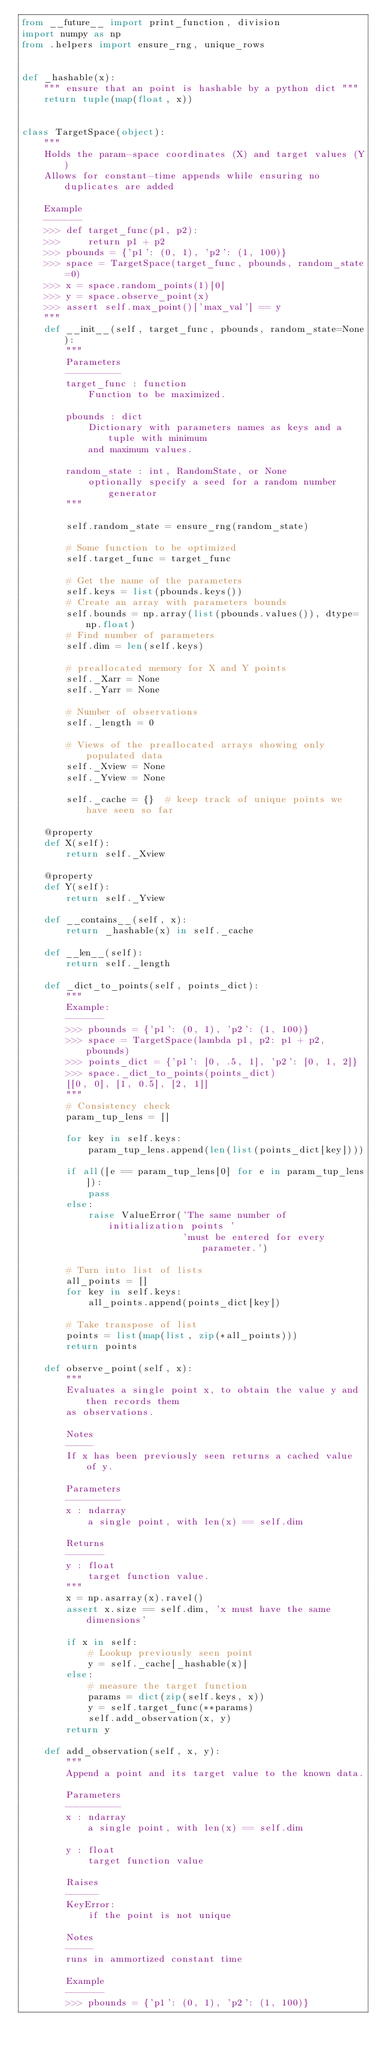Convert code to text. <code><loc_0><loc_0><loc_500><loc_500><_Python_>from __future__ import print_function, division
import numpy as np
from .helpers import ensure_rng, unique_rows


def _hashable(x):
    """ ensure that an point is hashable by a python dict """
    return tuple(map(float, x))


class TargetSpace(object):
    """
    Holds the param-space coordinates (X) and target values (Y)
    Allows for constant-time appends while ensuring no duplicates are added

    Example
    -------
    >>> def target_func(p1, p2):
    >>>     return p1 + p2
    >>> pbounds = {'p1': (0, 1), 'p2': (1, 100)}
    >>> space = TargetSpace(target_func, pbounds, random_state=0)
    >>> x = space.random_points(1)[0]
    >>> y = space.observe_point(x)
    >>> assert self.max_point()['max_val'] == y
    """
    def __init__(self, target_func, pbounds, random_state=None):
        """
        Parameters
        ----------
        target_func : function
            Function to be maximized.

        pbounds : dict
            Dictionary with parameters names as keys and a tuple with minimum
            and maximum values.

        random_state : int, RandomState, or None
            optionally specify a seed for a random number generator
        """

        self.random_state = ensure_rng(random_state)

        # Some function to be optimized
        self.target_func = target_func

        # Get the name of the parameters
        self.keys = list(pbounds.keys())
        # Create an array with parameters bounds
        self.bounds = np.array(list(pbounds.values()), dtype=np.float)
        # Find number of parameters
        self.dim = len(self.keys)

        # preallocated memory for X and Y points
        self._Xarr = None
        self._Yarr = None

        # Number of observations
        self._length = 0

        # Views of the preallocated arrays showing only populated data
        self._Xview = None
        self._Yview = None

        self._cache = {}  # keep track of unique points we have seen so far

    @property
    def X(self):
        return self._Xview

    @property
    def Y(self):
        return self._Yview

    def __contains__(self, x):
        return _hashable(x) in self._cache

    def __len__(self):
        return self._length

    def _dict_to_points(self, points_dict):
        """
        Example:
        -------
        >>> pbounds = {'p1': (0, 1), 'p2': (1, 100)}
        >>> space = TargetSpace(lambda p1, p2: p1 + p2, pbounds)
        >>> points_dict = {'p1': [0, .5, 1], 'p2': [0, 1, 2]}
        >>> space._dict_to_points(points_dict)
        [[0, 0], [1, 0.5], [2, 1]]
        """
        # Consistency check
        param_tup_lens = []

        for key in self.keys:
            param_tup_lens.append(len(list(points_dict[key])))

        if all([e == param_tup_lens[0] for e in param_tup_lens]):
            pass
        else:
            raise ValueError('The same number of initialization points '
                             'must be entered for every parameter.')

        # Turn into list of lists
        all_points = []
        for key in self.keys:
            all_points.append(points_dict[key])

        # Take transpose of list
        points = list(map(list, zip(*all_points)))
        return points

    def observe_point(self, x):
        """
        Evaluates a single point x, to obtain the value y and then records them
        as observations.

        Notes
        -----
        If x has been previously seen returns a cached value of y.

        Parameters
        ----------
        x : ndarray
            a single point, with len(x) == self.dim

        Returns
        -------
        y : float
            target function value.
        """
        x = np.asarray(x).ravel()
        assert x.size == self.dim, 'x must have the same dimensions'

        if x in self:
            # Lookup previously seen point
            y = self._cache[_hashable(x)]
        else:
            # measure the target function
            params = dict(zip(self.keys, x))
            y = self.target_func(**params)
            self.add_observation(x, y)
        return y

    def add_observation(self, x, y):
        """
        Append a point and its target value to the known data.

        Parameters
        ----------
        x : ndarray
            a single point, with len(x) == self.dim

        y : float
            target function value

        Raises
        ------
        KeyError:
            if the point is not unique

        Notes
        -----
        runs in ammortized constant time

        Example
        -------
        >>> pbounds = {'p1': (0, 1), 'p2': (1, 100)}</code> 